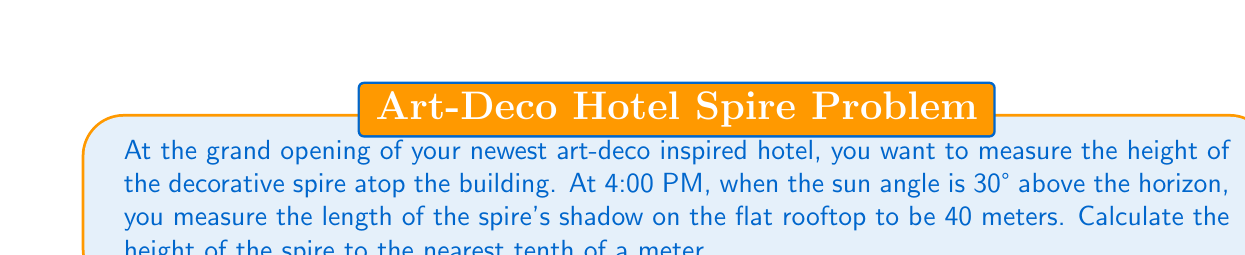Teach me how to tackle this problem. To solve this problem, we'll use trigonometry, specifically the tangent function. Let's break it down step-by-step:

1) First, let's visualize the scenario:

[asy]
import geometry;

size(200);
pair A = (0,0), B = (40,0), C = (0,20);
draw(A--B--C--A);
draw((-5,0)--(45,0),arrow=Arrow(TeXHead));
draw((0,-2)--(0,25),arrow=Arrow(TeXHead));
label("40 m", (20,0), S);
label("h", (0,10), W);
label("30°", (3,0), NE);
label("Shadow", (20,0), N);
label("Spire", (0,10), E);
label("Sun rays", (30,15), SE);

draw((30,15)--(40,0),dashed);
[/asy]

2) In this right-angled triangle:
   - The adjacent side is the length of the shadow (40 meters)
   - The opposite side is the height of the spire (h)
   - The angle between the ground and the sun's rays is 30°

3) We can use the tangent function, which is defined as:

   $$ \tan(\theta) = \frac{\text{opposite}}{\text{adjacent}} $$

4) Plugging in our known values:

   $$ \tan(30°) = \frac{h}{40} $$

5) We know that $\tan(30°) = \frac{1}{\sqrt{3}}$, so:

   $$ \frac{1}{\sqrt{3}} = \frac{h}{40} $$

6) Cross multiply:

   $$ 40 \cdot \frac{1}{\sqrt{3}} = h $$

7) Simplify:

   $$ h = \frac{40}{\sqrt{3}} $$

8) Calculate the result:

   $$ h \approx 23.094 \text{ meters} $$

9) Rounding to the nearest tenth:

   $$ h \approx 23.1 \text{ meters} $$
Answer: The height of the decorative spire is approximately 23.1 meters. 